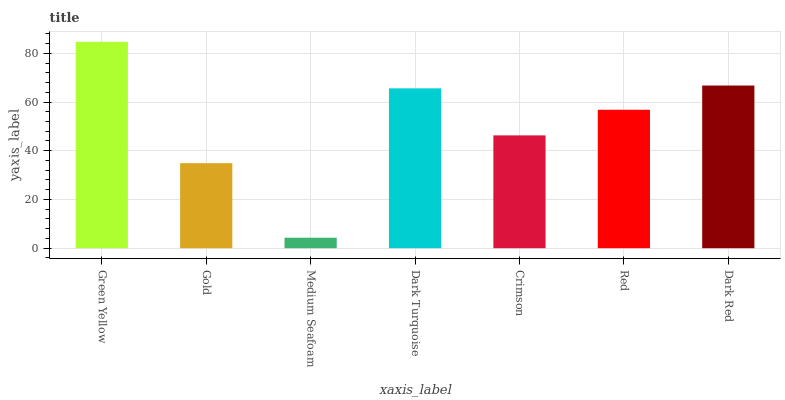Is Medium Seafoam the minimum?
Answer yes or no. Yes. Is Green Yellow the maximum?
Answer yes or no. Yes. Is Gold the minimum?
Answer yes or no. No. Is Gold the maximum?
Answer yes or no. No. Is Green Yellow greater than Gold?
Answer yes or no. Yes. Is Gold less than Green Yellow?
Answer yes or no. Yes. Is Gold greater than Green Yellow?
Answer yes or no. No. Is Green Yellow less than Gold?
Answer yes or no. No. Is Red the high median?
Answer yes or no. Yes. Is Red the low median?
Answer yes or no. Yes. Is Gold the high median?
Answer yes or no. No. Is Green Yellow the low median?
Answer yes or no. No. 